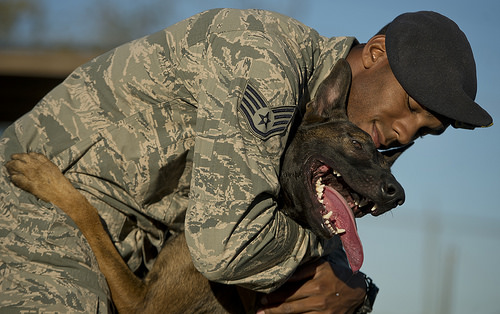<image>
Is the tongue on the man? No. The tongue is not positioned on the man. They may be near each other, but the tongue is not supported by or resting on top of the man. Is the man to the right of the dog? No. The man is not to the right of the dog. The horizontal positioning shows a different relationship. 